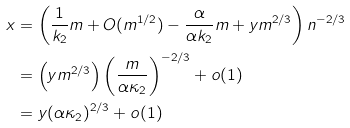Convert formula to latex. <formula><loc_0><loc_0><loc_500><loc_500>x & = \left ( \frac { 1 } { k _ { 2 } } m + O ( m ^ { 1 / 2 } ) - \frac { \alpha } { \alpha k _ { 2 } } m + y m ^ { 2 / 3 } \right ) n ^ { - 2 / 3 } \\ & = \left ( y m ^ { 2 / 3 } \right ) \left ( \frac { m } { \alpha \kappa _ { 2 } } \right ) ^ { - 2 / 3 } + o ( 1 ) \\ & = y ( \alpha \kappa _ { 2 } ) ^ { 2 / 3 } + o ( 1 )</formula> 